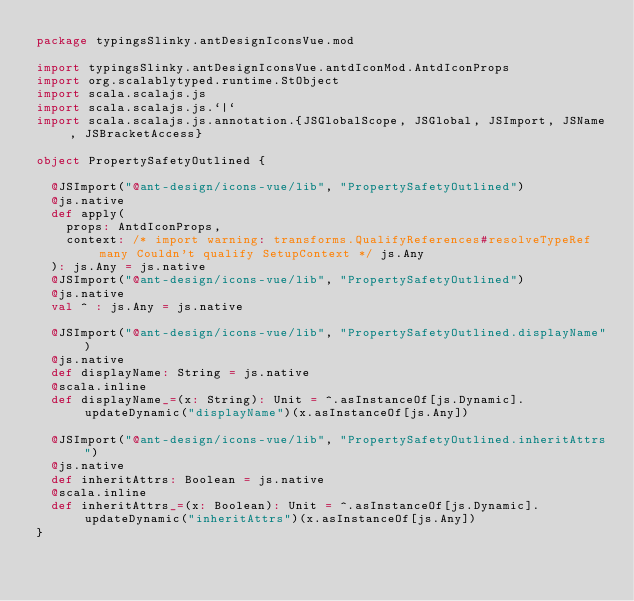Convert code to text. <code><loc_0><loc_0><loc_500><loc_500><_Scala_>package typingsSlinky.antDesignIconsVue.mod

import typingsSlinky.antDesignIconsVue.antdIconMod.AntdIconProps
import org.scalablytyped.runtime.StObject
import scala.scalajs.js
import scala.scalajs.js.`|`
import scala.scalajs.js.annotation.{JSGlobalScope, JSGlobal, JSImport, JSName, JSBracketAccess}

object PropertySafetyOutlined {
  
  @JSImport("@ant-design/icons-vue/lib", "PropertySafetyOutlined")
  @js.native
  def apply(
    props: AntdIconProps,
    context: /* import warning: transforms.QualifyReferences#resolveTypeRef many Couldn't qualify SetupContext */ js.Any
  ): js.Any = js.native
  @JSImport("@ant-design/icons-vue/lib", "PropertySafetyOutlined")
  @js.native
  val ^ : js.Any = js.native
  
  @JSImport("@ant-design/icons-vue/lib", "PropertySafetyOutlined.displayName")
  @js.native
  def displayName: String = js.native
  @scala.inline
  def displayName_=(x: String): Unit = ^.asInstanceOf[js.Dynamic].updateDynamic("displayName")(x.asInstanceOf[js.Any])
  
  @JSImport("@ant-design/icons-vue/lib", "PropertySafetyOutlined.inheritAttrs")
  @js.native
  def inheritAttrs: Boolean = js.native
  @scala.inline
  def inheritAttrs_=(x: Boolean): Unit = ^.asInstanceOf[js.Dynamic].updateDynamic("inheritAttrs")(x.asInstanceOf[js.Any])
}
</code> 